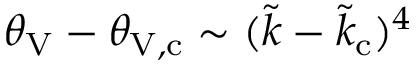<formula> <loc_0><loc_0><loc_500><loc_500>\theta _ { V } - \theta _ { V , c } \sim ( \tilde { k } - \tilde { k } _ { c } ) ^ { 4 }</formula> 